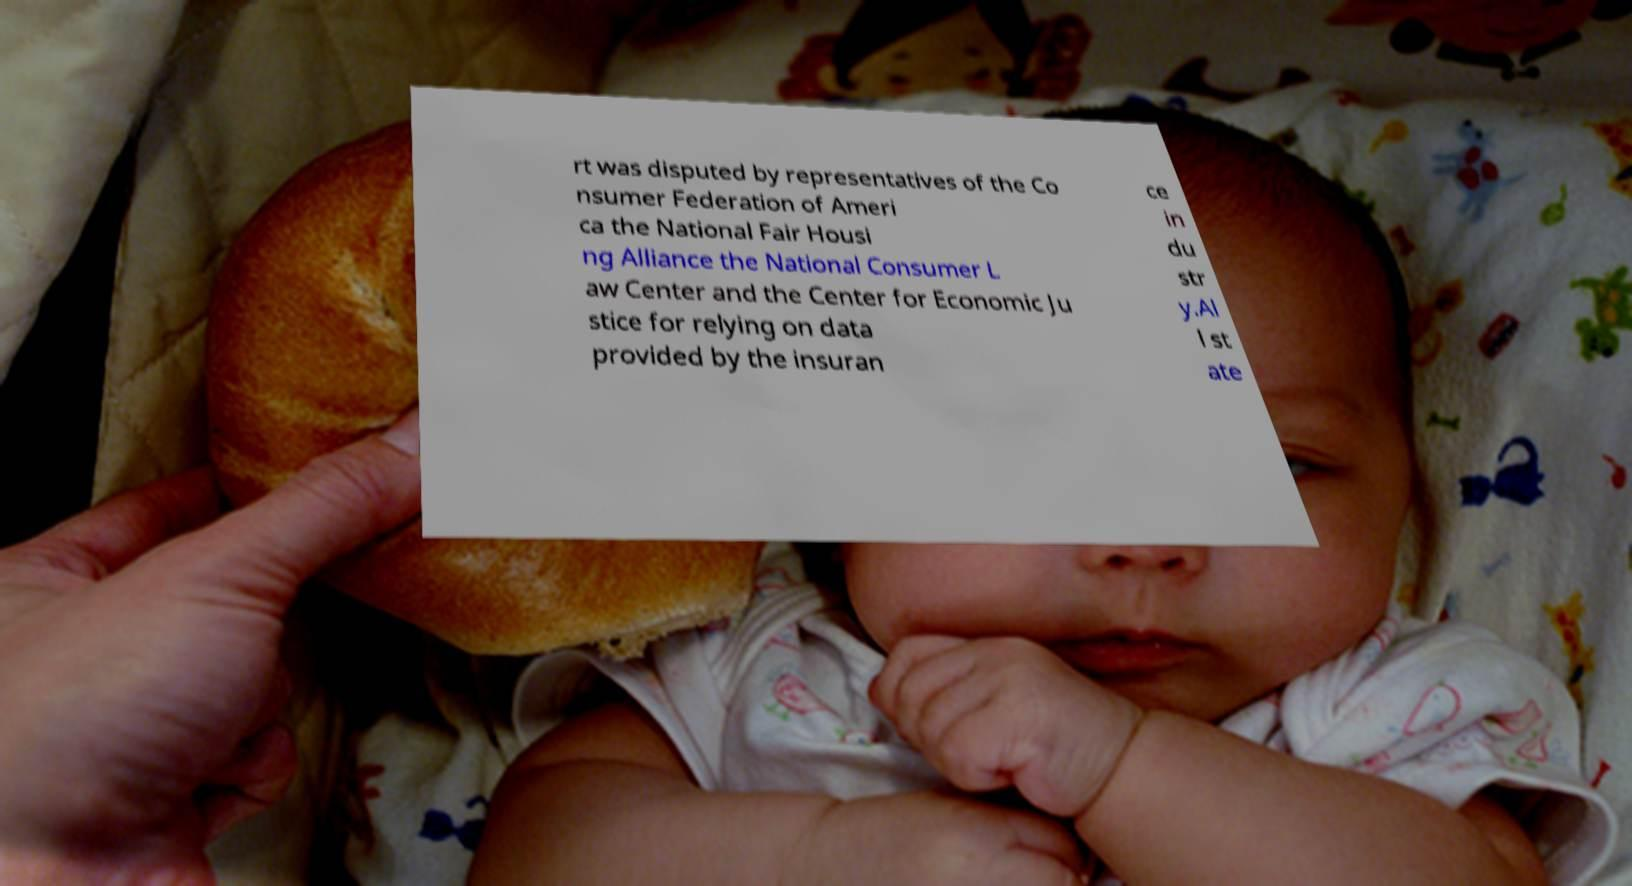Can you accurately transcribe the text from the provided image for me? rt was disputed by representatives of the Co nsumer Federation of Ameri ca the National Fair Housi ng Alliance the National Consumer L aw Center and the Center for Economic Ju stice for relying on data provided by the insuran ce in du str y.Al l st ate 